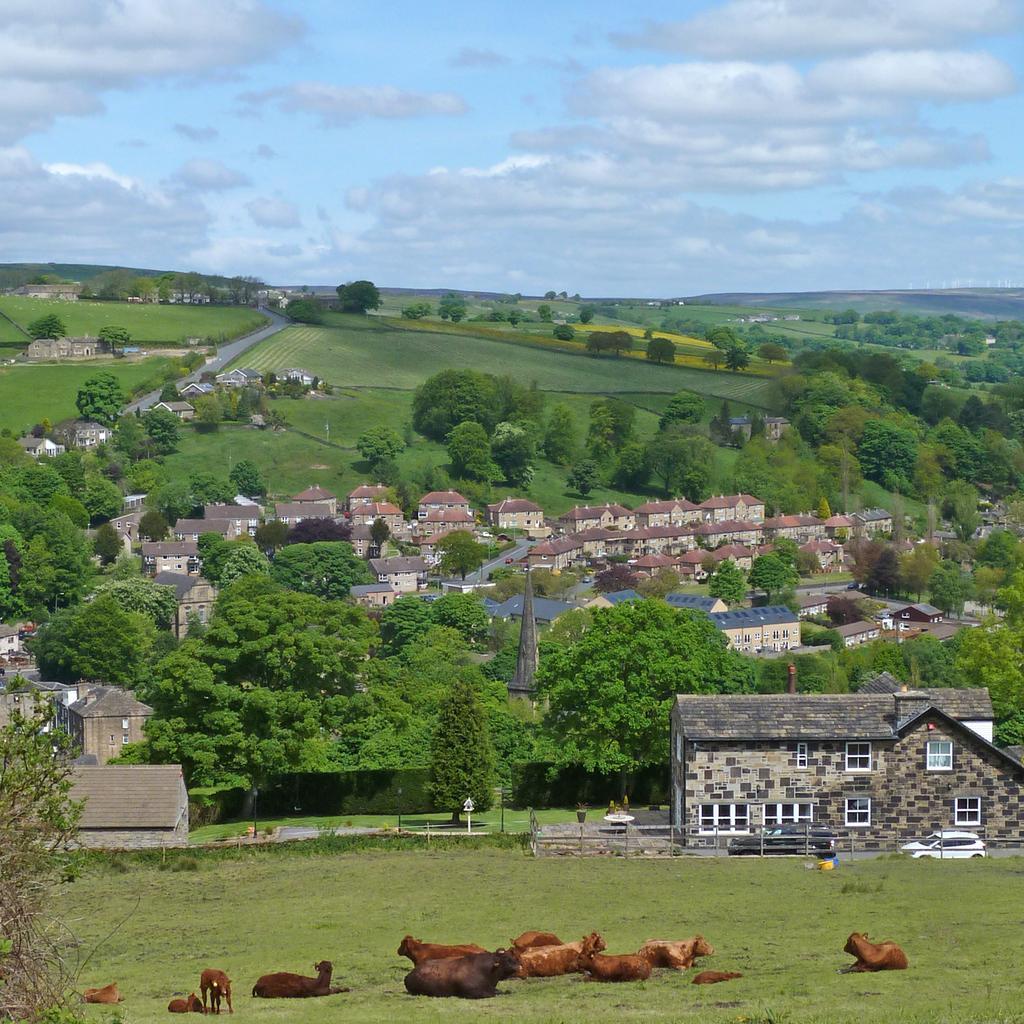Describe this image in one or two sentences. In this image I can see many animals which are in brown color. These are on the ground. In the background I can see many buildings, trees and I can see the road and the ground. I can see the clouds and the sky. 